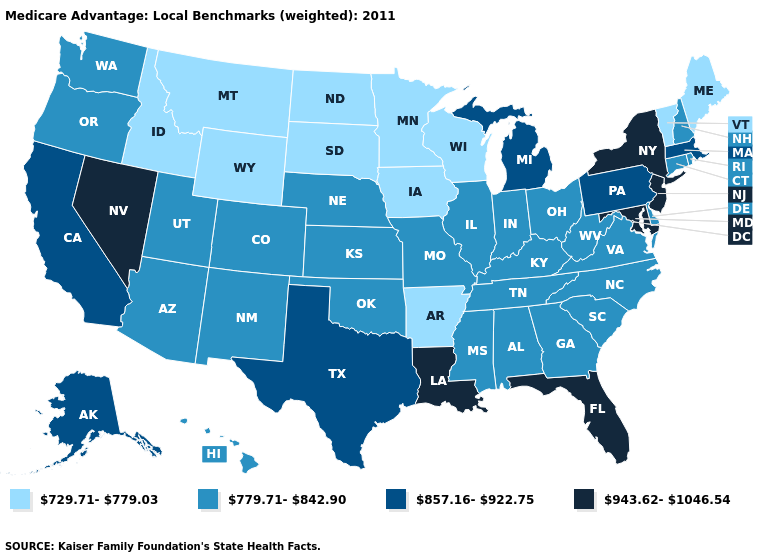What is the lowest value in the USA?
Concise answer only. 729.71-779.03. Does Alaska have the same value as Virginia?
Give a very brief answer. No. What is the value of Kansas?
Give a very brief answer. 779.71-842.90. What is the highest value in the MidWest ?
Answer briefly. 857.16-922.75. Which states have the highest value in the USA?
Short answer required. Florida, Louisiana, Maryland, New Jersey, Nevada, New York. What is the highest value in the South ?
Give a very brief answer. 943.62-1046.54. What is the highest value in the South ?
Quick response, please. 943.62-1046.54. Does Vermont have the lowest value in the USA?
Write a very short answer. Yes. What is the value of Missouri?
Write a very short answer. 779.71-842.90. What is the highest value in the West ?
Quick response, please. 943.62-1046.54. What is the lowest value in the West?
Quick response, please. 729.71-779.03. What is the value of Wyoming?
Keep it brief. 729.71-779.03. Name the states that have a value in the range 857.16-922.75?
Answer briefly. Alaska, California, Massachusetts, Michigan, Pennsylvania, Texas. Name the states that have a value in the range 943.62-1046.54?
Short answer required. Florida, Louisiana, Maryland, New Jersey, Nevada, New York. Does Arkansas have the lowest value in the USA?
Write a very short answer. Yes. 